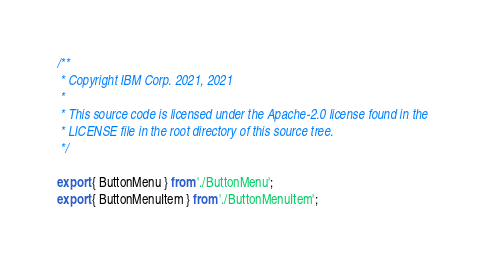Convert code to text. <code><loc_0><loc_0><loc_500><loc_500><_JavaScript_>/**
 * Copyright IBM Corp. 2021, 2021
 *
 * This source code is licensed under the Apache-2.0 license found in the
 * LICENSE file in the root directory of this source tree.
 */

export { ButtonMenu } from './ButtonMenu';
export { ButtonMenuItem } from './ButtonMenuItem';
</code> 